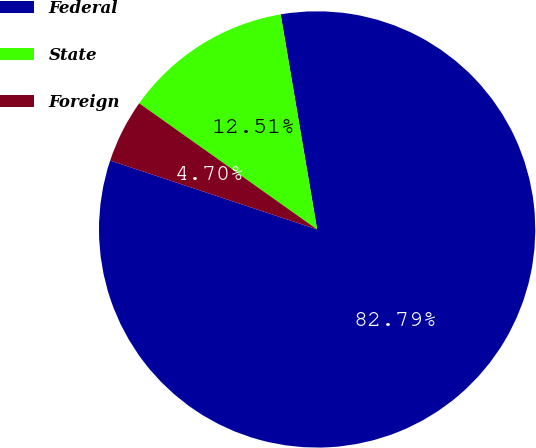Convert chart to OTSL. <chart><loc_0><loc_0><loc_500><loc_500><pie_chart><fcel>Federal<fcel>State<fcel>Foreign<nl><fcel>82.79%<fcel>12.51%<fcel>4.7%<nl></chart> 